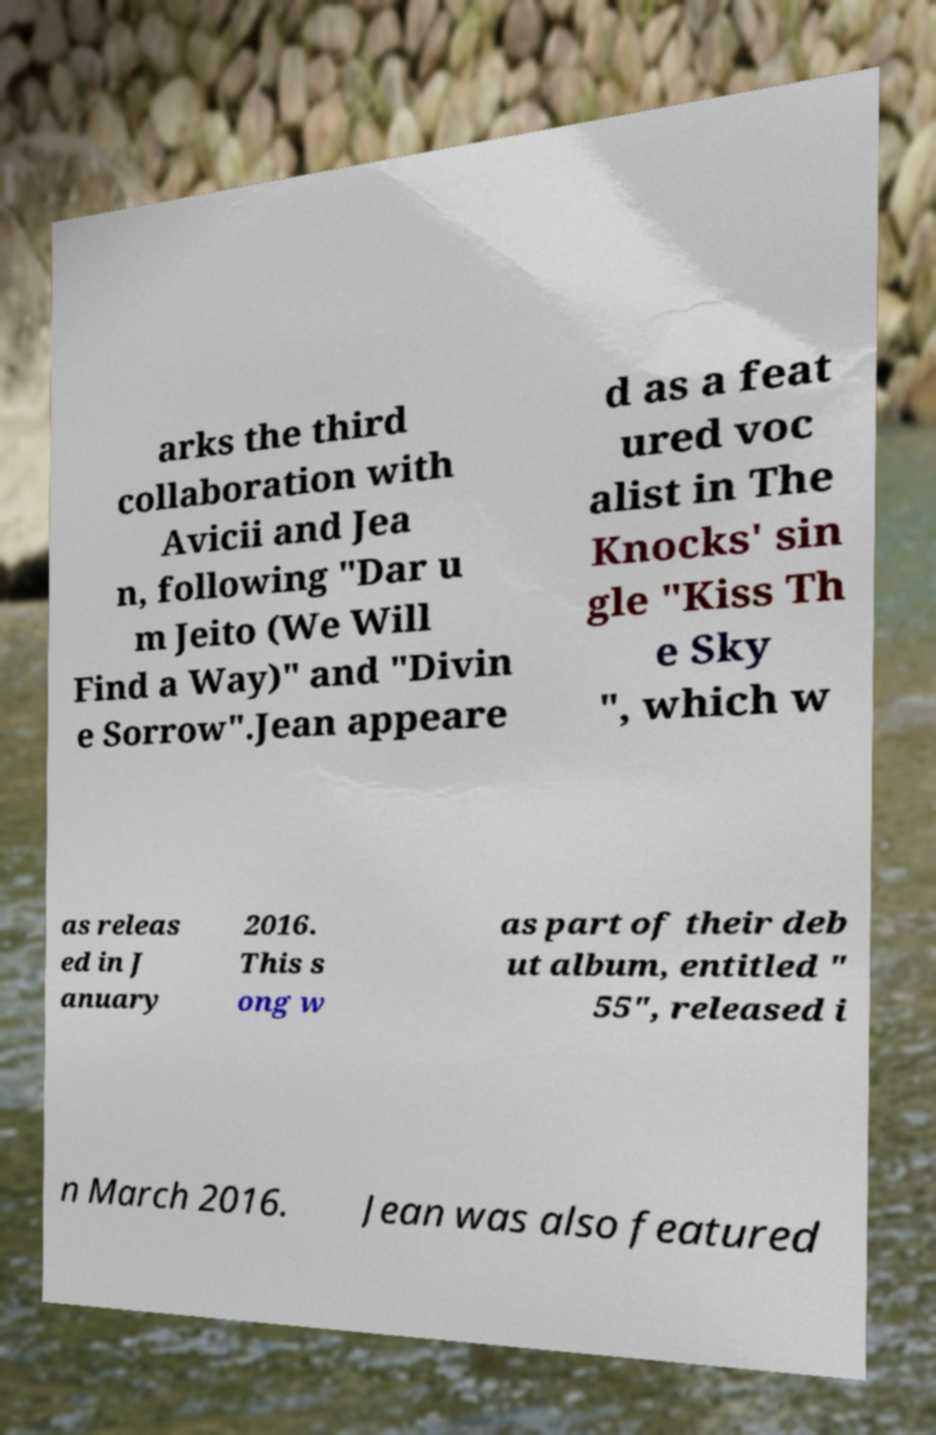Could you assist in decoding the text presented in this image and type it out clearly? arks the third collaboration with Avicii and Jea n, following "Dar u m Jeito (We Will Find a Way)" and "Divin e Sorrow".Jean appeare d as a feat ured voc alist in The Knocks' sin gle "Kiss Th e Sky ", which w as releas ed in J anuary 2016. This s ong w as part of their deb ut album, entitled " 55", released i n March 2016. Jean was also featured 